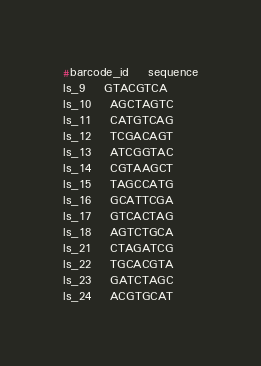<code> <loc_0><loc_0><loc_500><loc_500><_SQL_>#barcode_id	sequence
ls_9	GTACGTCA
ls_10	AGCTAGTC
ls_11	CATGTCAG
ls_12	TCGACAGT
ls_13	ATCGGTAC
ls_14	CGTAAGCT
ls_15	TAGCCATG
ls_16	GCATTCGA
ls_17	GTCACTAG
ls_18	AGTCTGCA
ls_21	CTAGATCG
ls_22	TGCACGTA
ls_23	GATCTAGC
ls_24	ACGTGCAT</code> 